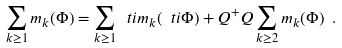<formula> <loc_0><loc_0><loc_500><loc_500>\sum _ { k \geq 1 } m _ { k } ( \Phi ) = \sum _ { k \geq 1 } \ t i { m } _ { k } ( \ t i \Phi ) + Q ^ { + } Q \sum _ { k \geq 2 } m _ { k } ( \Phi ) \ .</formula> 